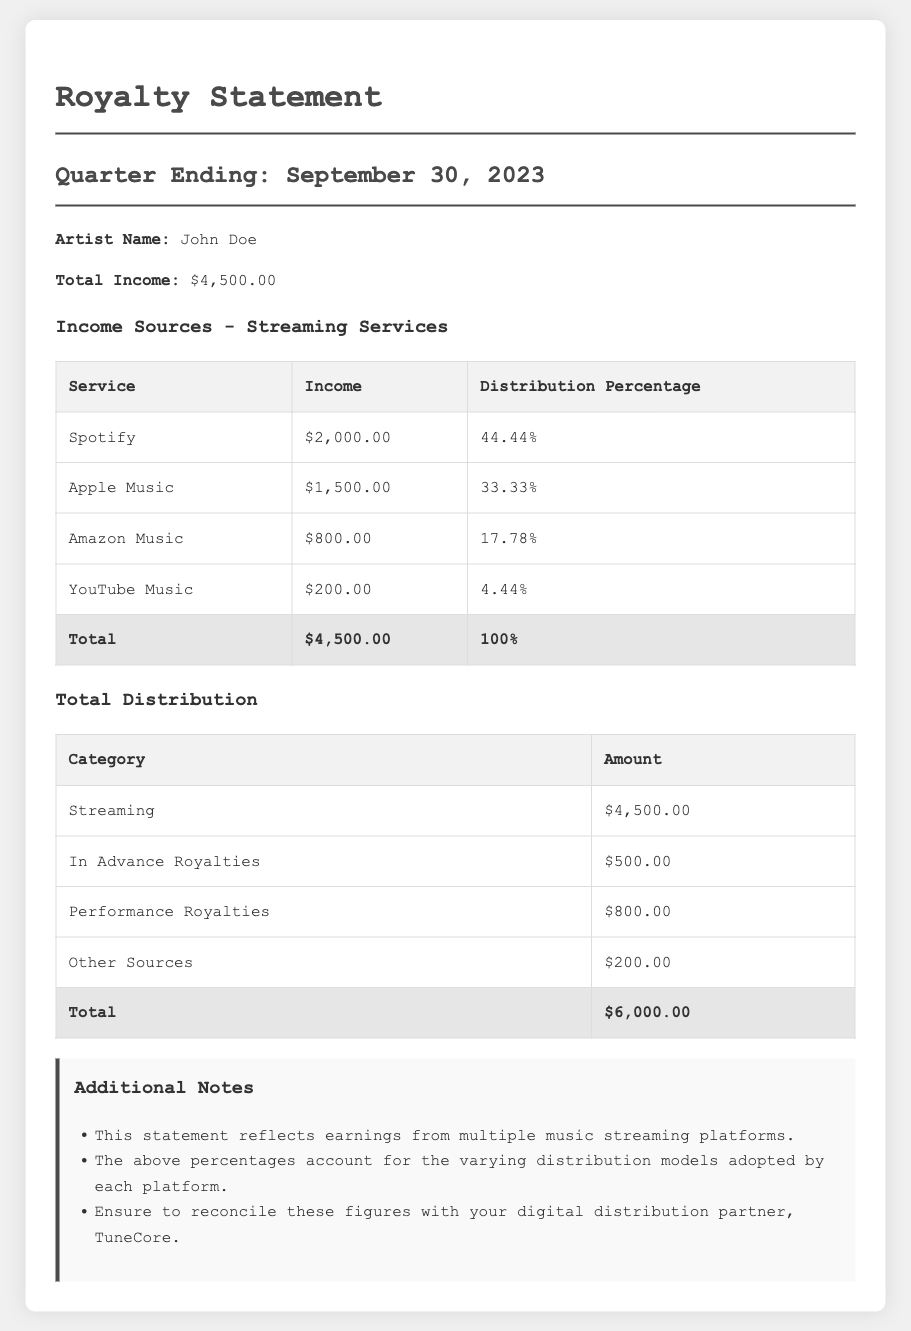What is the artist's name? The artist's name is explicitly stated in the document under the artist name section.
Answer: John Doe What is the total income for the quarter? The total income is listed in the document as part of the financial summary.
Answer: $4,500.00 Which streaming service generated the highest income? By comparing the income amounts for each service, we can determine which one had the highest revenue.
Answer: Spotify What percentage of the total income came from Apple Music? The document provides the distribution percentage for Apple Music, allowing us to answer this.
Answer: 33.33% What is the amount listed for Performance Royalties? The specific amount for Performance Royalties is given in the total distribution section.
Answer: $800.00 What is the total amount from Other Sources? This figure can be found in the total distribution table; it specifies the amount for Other Sources.
Answer: $200.00 How much income does YouTube Music contribute? The income from YouTube Music is shown in the income sources table for streaming services.
Answer: $200.00 What is the total income from all streaming services listed? This total can be calculated by adding all the incomes from the individual streaming services in the table.
Answer: $4,500.00 What should be reconciled with TuneCore? The document includes notes that specify the need for reconciliation with a particular partner.
Answer: These figures 